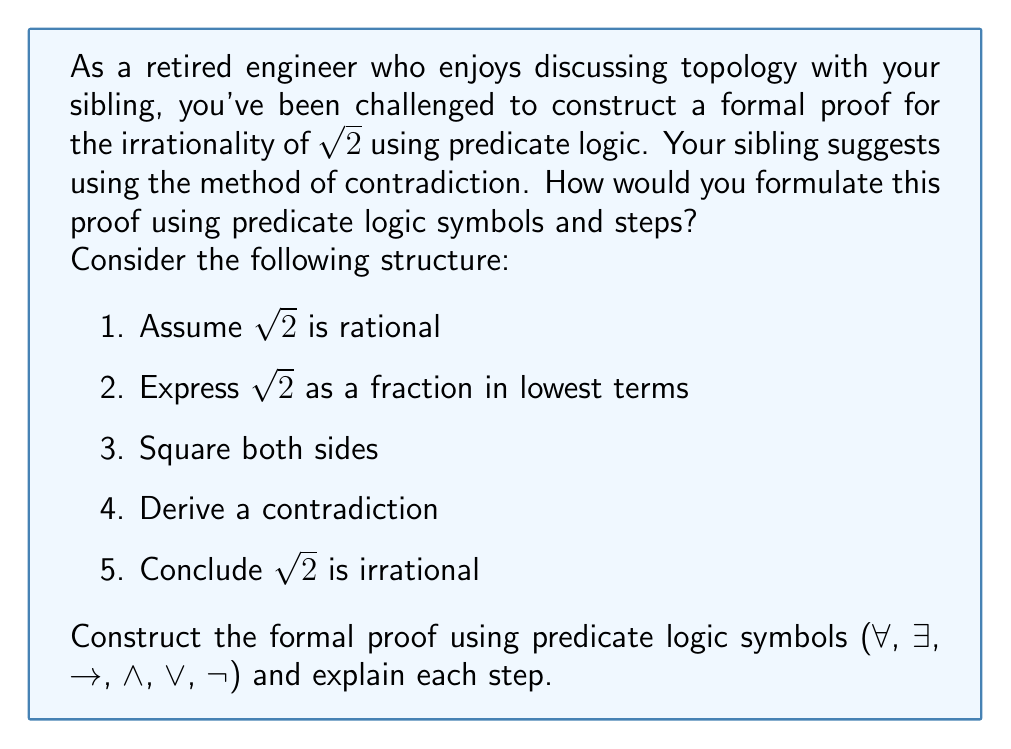Help me with this question. Let's construct the formal proof for the irrationality of $\sqrt{2}$ using predicate logic:

1. Assume $\sqrt{2}$ is rational:
   $\exists p \exists q (q \neq 0 \wedge \sqrt{2} = \frac{p}{q} \wedge \gcd(p,q) = 1)$

2. Express $\sqrt{2}$ as a fraction:
   $\sqrt{2} = \frac{p}{q}$

3. Square both sides:
   $2 = \frac{p^2}{q^2}$

4. Multiply both sides by $q^2$:
   $2q^2 = p^2$

5. This implies $p^2$ is even:
   $\exists k (p^2 = 2k)$

6. If $p^2$ is even, then $p$ is even:
   $\exists m (p = 2m)$

7. Substitute $p = 2m$ into $2q^2 = p^2$:
   $2q^2 = (2m)^2 = 4m^2$

8. Simplify:
   $q^2 = 2m^2$

9. This implies $q^2$ is even, so $q$ is even:
   $\exists n (q = 2n)$

10. We have shown both $p$ and $q$ are even, contradicting $\gcd(p,q) = 1$:
    $(\exists m (p = 2m) \wedge \exists n (q = 2n)) \rightarrow \neg(\gcd(p,q) = 1)$

11. This contradiction proves our initial assumption was false:
    $\neg(\exists p \exists q (q \neq 0 \wedge \sqrt{2} = \frac{p}{q} \wedge \gcd(p,q) = 1))$

12. Therefore, $\sqrt{2}$ is irrational:
    $\forall p \forall q (q \neq 0 \rightarrow \sqrt{2} \neq \frac{p}{q})$

Each step in this proof uses predicate logic symbols and follows from the previous steps, leading to the conclusion that $\sqrt{2}$ is irrational.
Answer: $\neg(\exists p \exists q (q \neq 0 \wedge \sqrt{2} = \frac{p}{q} \wedge \gcd(p,q) = 1)) \rightarrow \forall p \forall q (q \neq 0 \rightarrow \sqrt{2} \neq \frac{p}{q})$ 